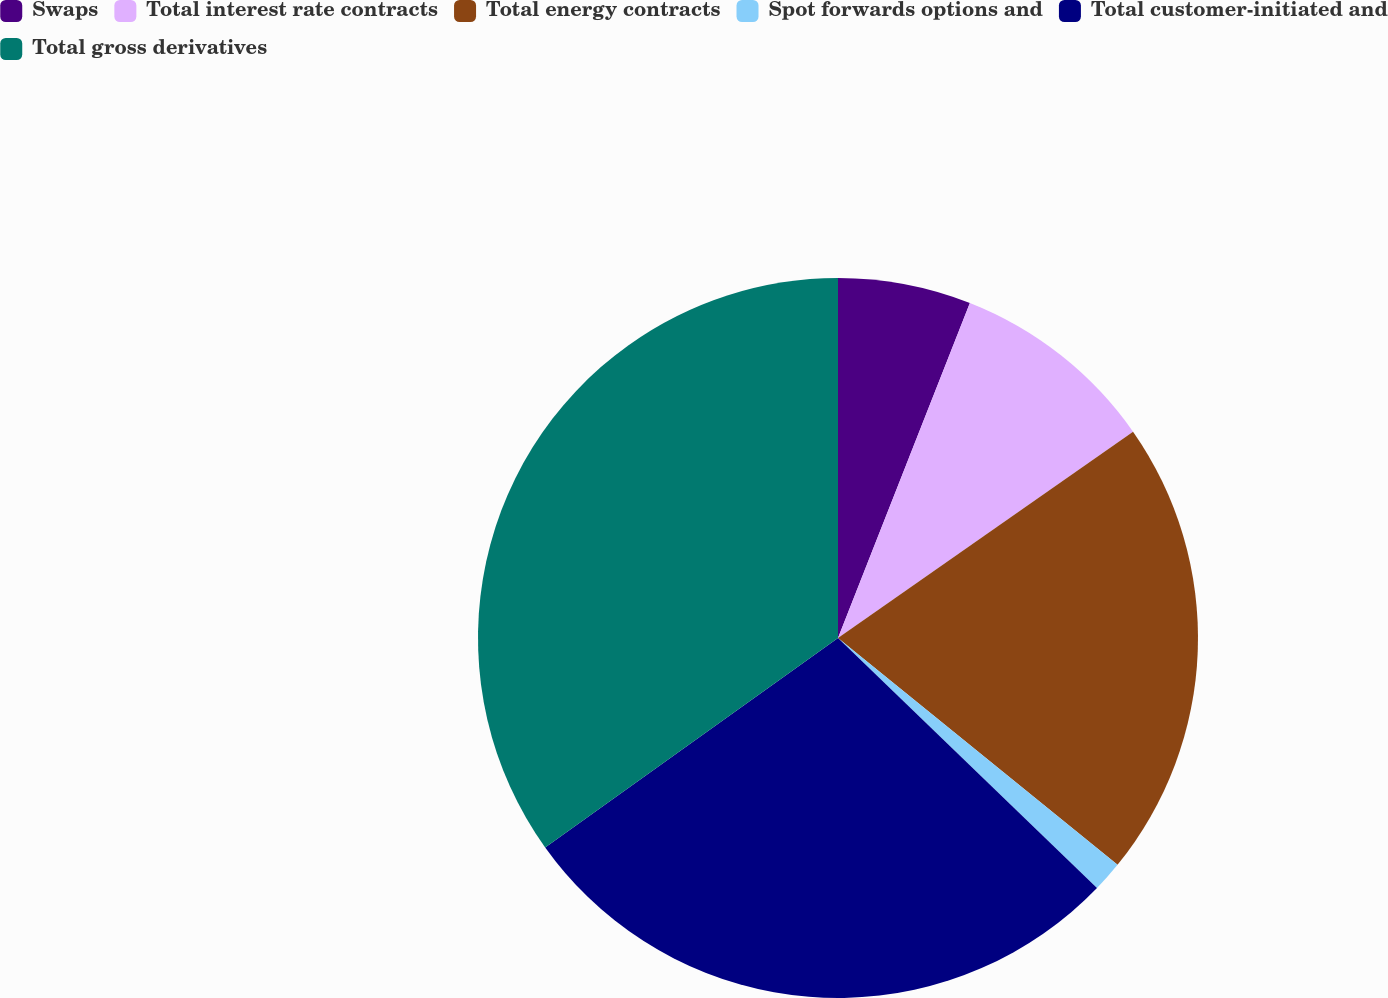<chart> <loc_0><loc_0><loc_500><loc_500><pie_chart><fcel>Swaps<fcel>Total interest rate contracts<fcel>Total energy contracts<fcel>Spot forwards options and<fcel>Total customer-initiated and<fcel>Total gross derivatives<nl><fcel>5.97%<fcel>9.32%<fcel>20.56%<fcel>1.37%<fcel>27.9%<fcel>34.88%<nl></chart> 